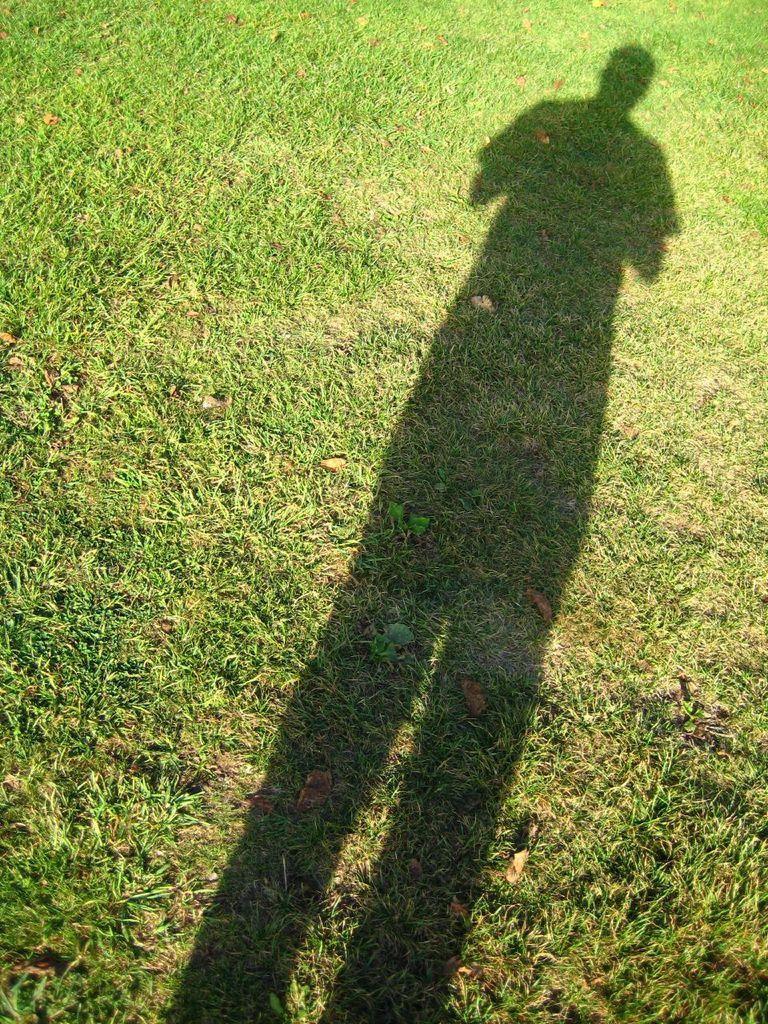What can be seen on the ground in the image? There is a shadow of a human on the ground in the image. What type of vegetation is present on the ground in the image? There is grass on the ground in the image. What type of tongue can be seen in the image? There is no tongue present in the image. What statement can be made about the agreement between the shadow and the grass in the image? There is no agreement between the shadow and the grass in the image, as they are separate elements in the image. 